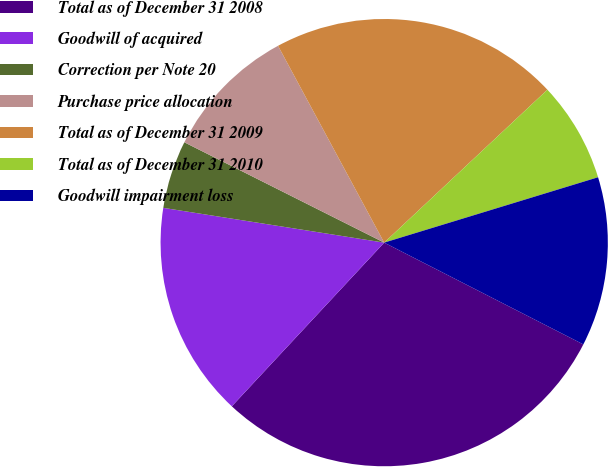Convert chart. <chart><loc_0><loc_0><loc_500><loc_500><pie_chart><fcel>Total as of December 31 2008<fcel>Goodwill of acquired<fcel>Correction per Note 20<fcel>Purchase price allocation<fcel>Total as of December 31 2009<fcel>Total as of December 31 2010<fcel>Goodwill impairment loss<nl><fcel>29.41%<fcel>15.55%<fcel>4.92%<fcel>9.72%<fcel>20.89%<fcel>7.26%<fcel>12.24%<nl></chart> 